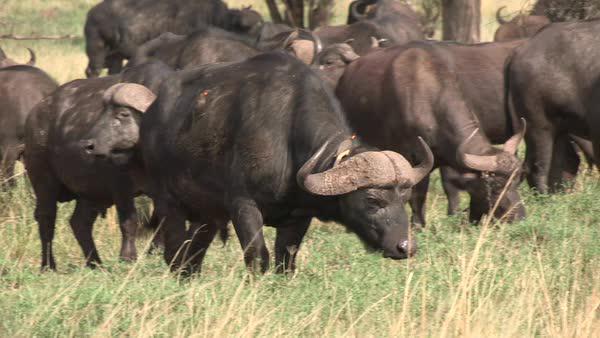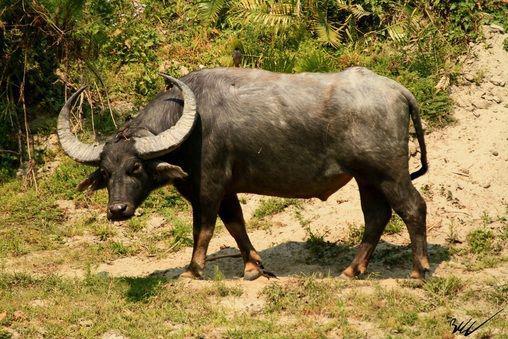The first image is the image on the left, the second image is the image on the right. For the images displayed, is the sentence "There are at most 5 water buffalo." factually correct? Answer yes or no. No. The first image is the image on the left, the second image is the image on the right. For the images displayed, is the sentence "There are fewer than 5 water buffalos" factually correct? Answer yes or no. No. 